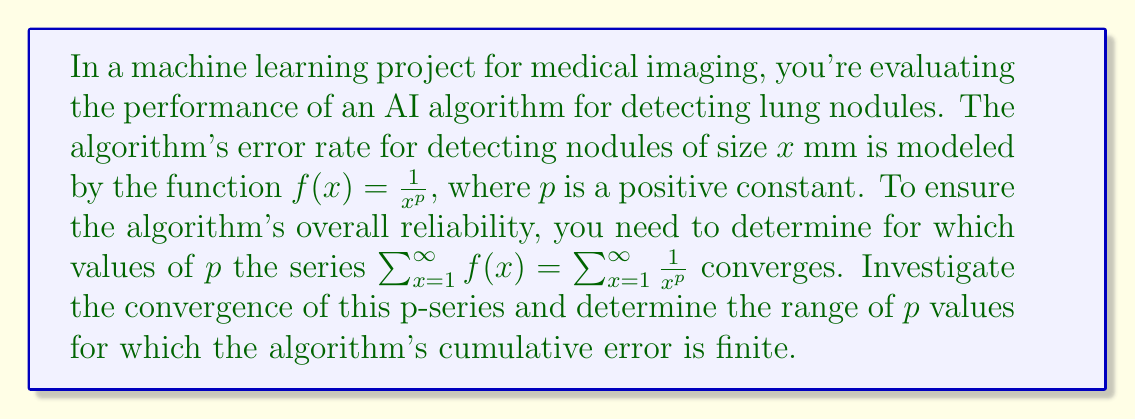Provide a solution to this math problem. To investigate the convergence of the p-series $\sum_{x=1}^{\infty} \frac{1}{x^p}$, we can use the p-series test:

1) The p-series $\sum_{x=1}^{\infty} \frac{1}{x^p}$ converges if and only if $p > 1$.

2) Let's break this down:

   a) If $p \leq 0$, each term $\frac{1}{x^p}$ is greater than or equal to 1, so the series clearly diverges.

   b) For $0 < p \leq 1$, we can use the integral test:
      
      Let $f(x) = \frac{1}{x^p}$. Then,
      
      $$\int_1^{\infty} f(x) dx = \int_1^{\infty} \frac{1}{x^p} dx = \lim_{b \to \infty} \left[\frac{x^{1-p}}{1-p}\right]_1^b = \lim_{b \to \infty} \left(\frac{b^{1-p}}{1-p} - \frac{1}{1-p}\right)$$
      
      When $0 < p < 1$, this limit is infinite.
      When $p = 1$, the integral becomes $\lim_{b \to \infty} \ln(b)$, which is also infinite.

      Therefore, by the integral test, the series diverges for $0 < p \leq 1$.

   c) For $p > 1$, the integral converges:
      
      $$\int_1^{\infty} \frac{1}{x^p} dx = \lim_{b \to \infty} \left[\frac{x^{1-p}}{1-p}\right]_1^b = \frac{1}{p-1}$$

      Therefore, by the integral test, the series converges for $p > 1$.

3) In the context of the AI algorithm, this means that the cumulative error will be finite (i.e., the error series will converge) only when $p > 1$.
Answer: The p-series $\sum_{x=1}^{\infty} \frac{1}{x^p}$ converges for $p > 1$. Therefore, the AI algorithm's cumulative error will be finite only when $p > 1$. 